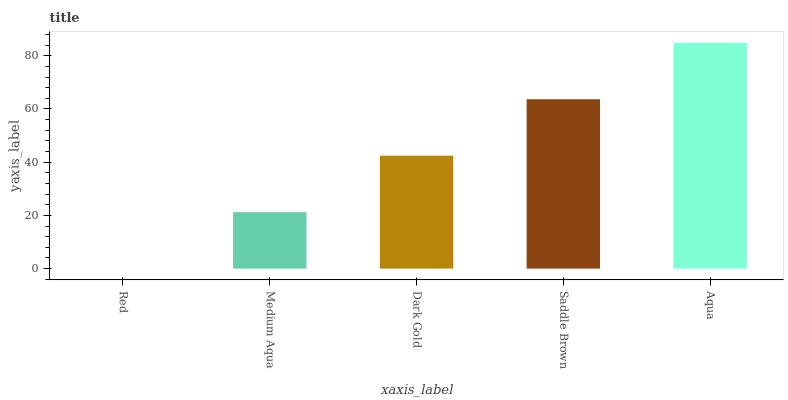Is Red the minimum?
Answer yes or no. Yes. Is Aqua the maximum?
Answer yes or no. Yes. Is Medium Aqua the minimum?
Answer yes or no. No. Is Medium Aqua the maximum?
Answer yes or no. No. Is Medium Aqua greater than Red?
Answer yes or no. Yes. Is Red less than Medium Aqua?
Answer yes or no. Yes. Is Red greater than Medium Aqua?
Answer yes or no. No. Is Medium Aqua less than Red?
Answer yes or no. No. Is Dark Gold the high median?
Answer yes or no. Yes. Is Dark Gold the low median?
Answer yes or no. Yes. Is Aqua the high median?
Answer yes or no. No. Is Aqua the low median?
Answer yes or no. No. 